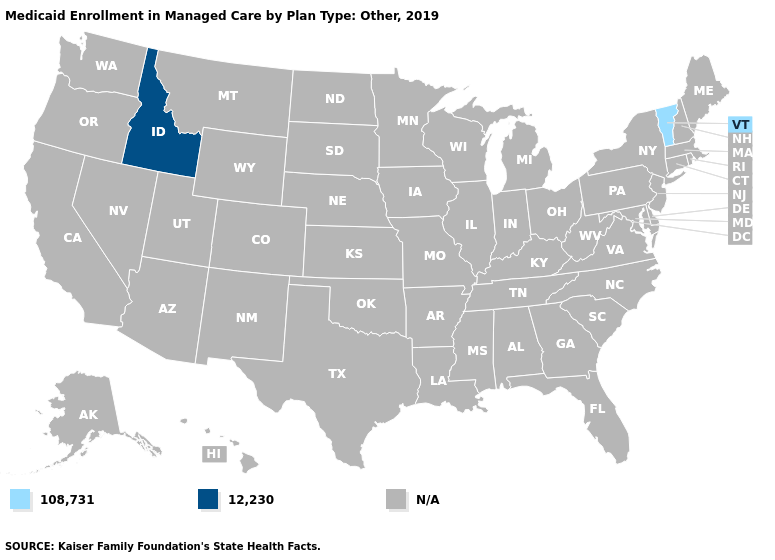Which states have the lowest value in the Northeast?
Write a very short answer. Vermont. Which states have the lowest value in the USA?
Quick response, please. Vermont. Which states have the lowest value in the USA?
Give a very brief answer. Vermont. What is the value of Hawaii?
Quick response, please. N/A. What is the highest value in the West ?
Give a very brief answer. 12,230. Name the states that have a value in the range 12,230?
Concise answer only. Idaho. What is the value of Wisconsin?
Write a very short answer. N/A. Among the states that border Massachusetts , which have the lowest value?
Give a very brief answer. Vermont. How many symbols are there in the legend?
Concise answer only. 3. What is the value of Texas?
Keep it brief. N/A. What is the value of Tennessee?
Keep it brief. N/A. 